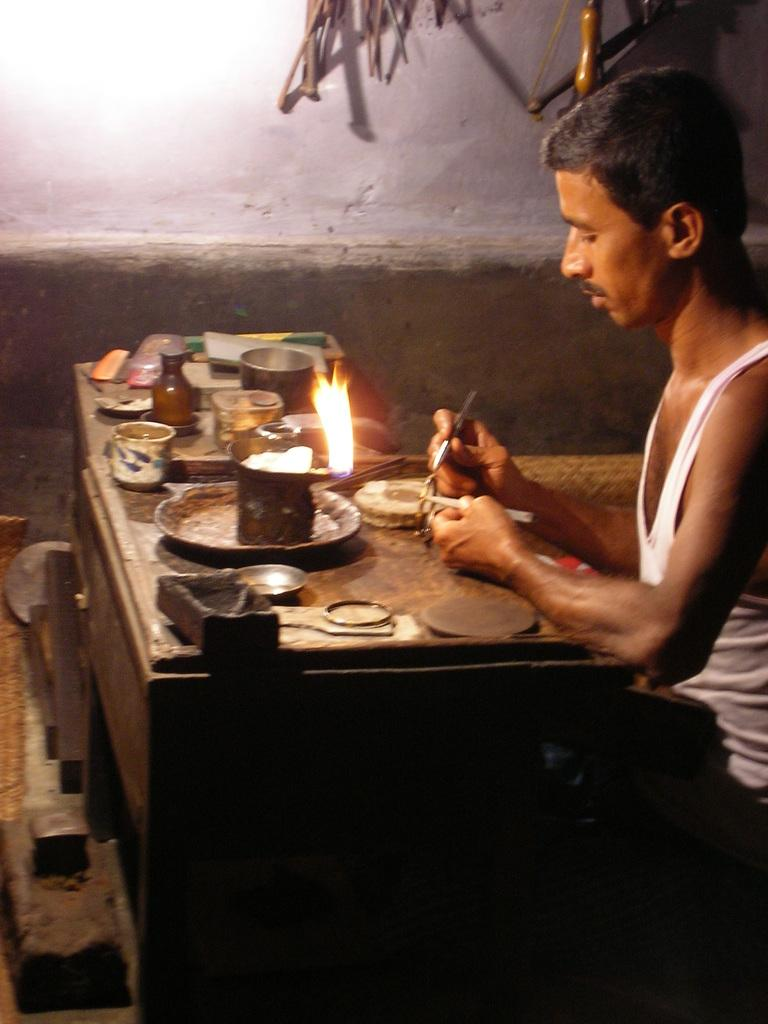What is the person in the image doing? The person is sitting and working in the image. Where is the person located in the image? The person is sitting at the rightmost part of the image. What can be seen on the table in the image? There are objects placed on a table in the image. What type of bird can be seen flying in the image? There is no bird present in the image. Is there any smoke coming from the objects on the table in the image? There is no smoke visible in the image. 